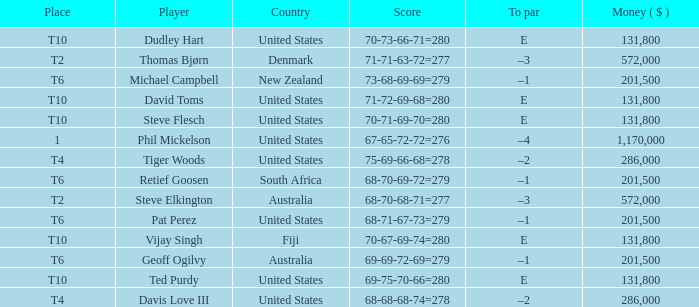What is the largest money for a t4 place, for Tiger Woods? 286000.0. 